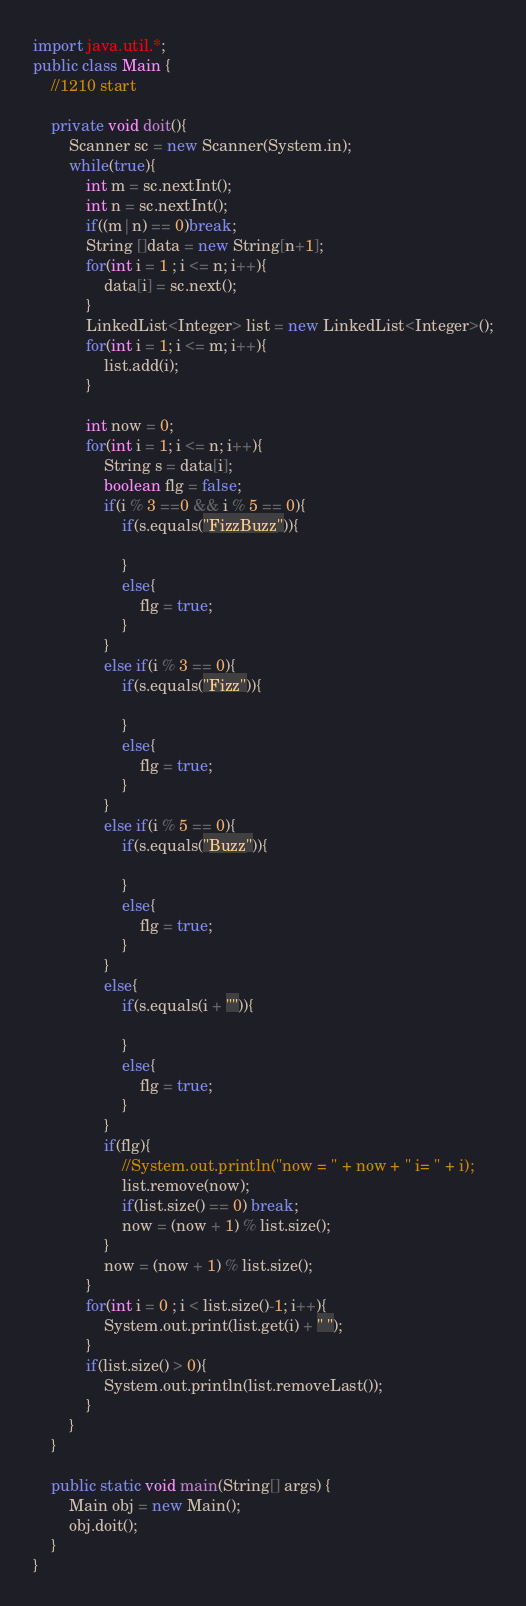<code> <loc_0><loc_0><loc_500><loc_500><_Java_>
import java.util.*;
public class Main {
	//1210 start
	
	private void doit(){
		Scanner sc = new Scanner(System.in);
		while(true){
			int m = sc.nextInt();
			int n = sc.nextInt();
			if((m|n) == 0)break;
			String []data = new String[n+1];
			for(int i = 1 ; i <= n; i++){
				data[i] = sc.next();
			}
			LinkedList<Integer> list = new LinkedList<Integer>();
			for(int i = 1; i <= m; i++){
				list.add(i);
			}
			
			int now = 0;
			for(int i = 1; i <= n; i++){
				String s = data[i];
				boolean flg = false;
				if(i % 3 ==0 && i % 5 == 0){
					if(s.equals("FizzBuzz")){
						
					}
					else{
						flg = true;
					}
				}
				else if(i % 3 == 0){
					if(s.equals("Fizz")){
						
					}
					else{
						flg = true;
					}
				}
				else if(i % 5 == 0){
					if(s.equals("Buzz")){
						
					}
					else{
						flg = true;
					}
				}
				else{
					if(s.equals(i + "")){
						
					}
					else{
						flg = true;
					}
				}
				if(flg){
					//System.out.println("now = " + now + " i= " + i);
					list.remove(now);
					if(list.size() == 0) break;
					now = (now + 1) % list.size();
				}
				now = (now + 1) % list.size();
			}
			for(int i = 0 ; i < list.size()-1; i++){
				System.out.print(list.get(i) + " ");
			}
			if(list.size() > 0){
				System.out.println(list.removeLast());
			}
		}
	}

	public static void main(String[] args) {
		Main obj = new Main();
		obj.doit();
	}
}</code> 